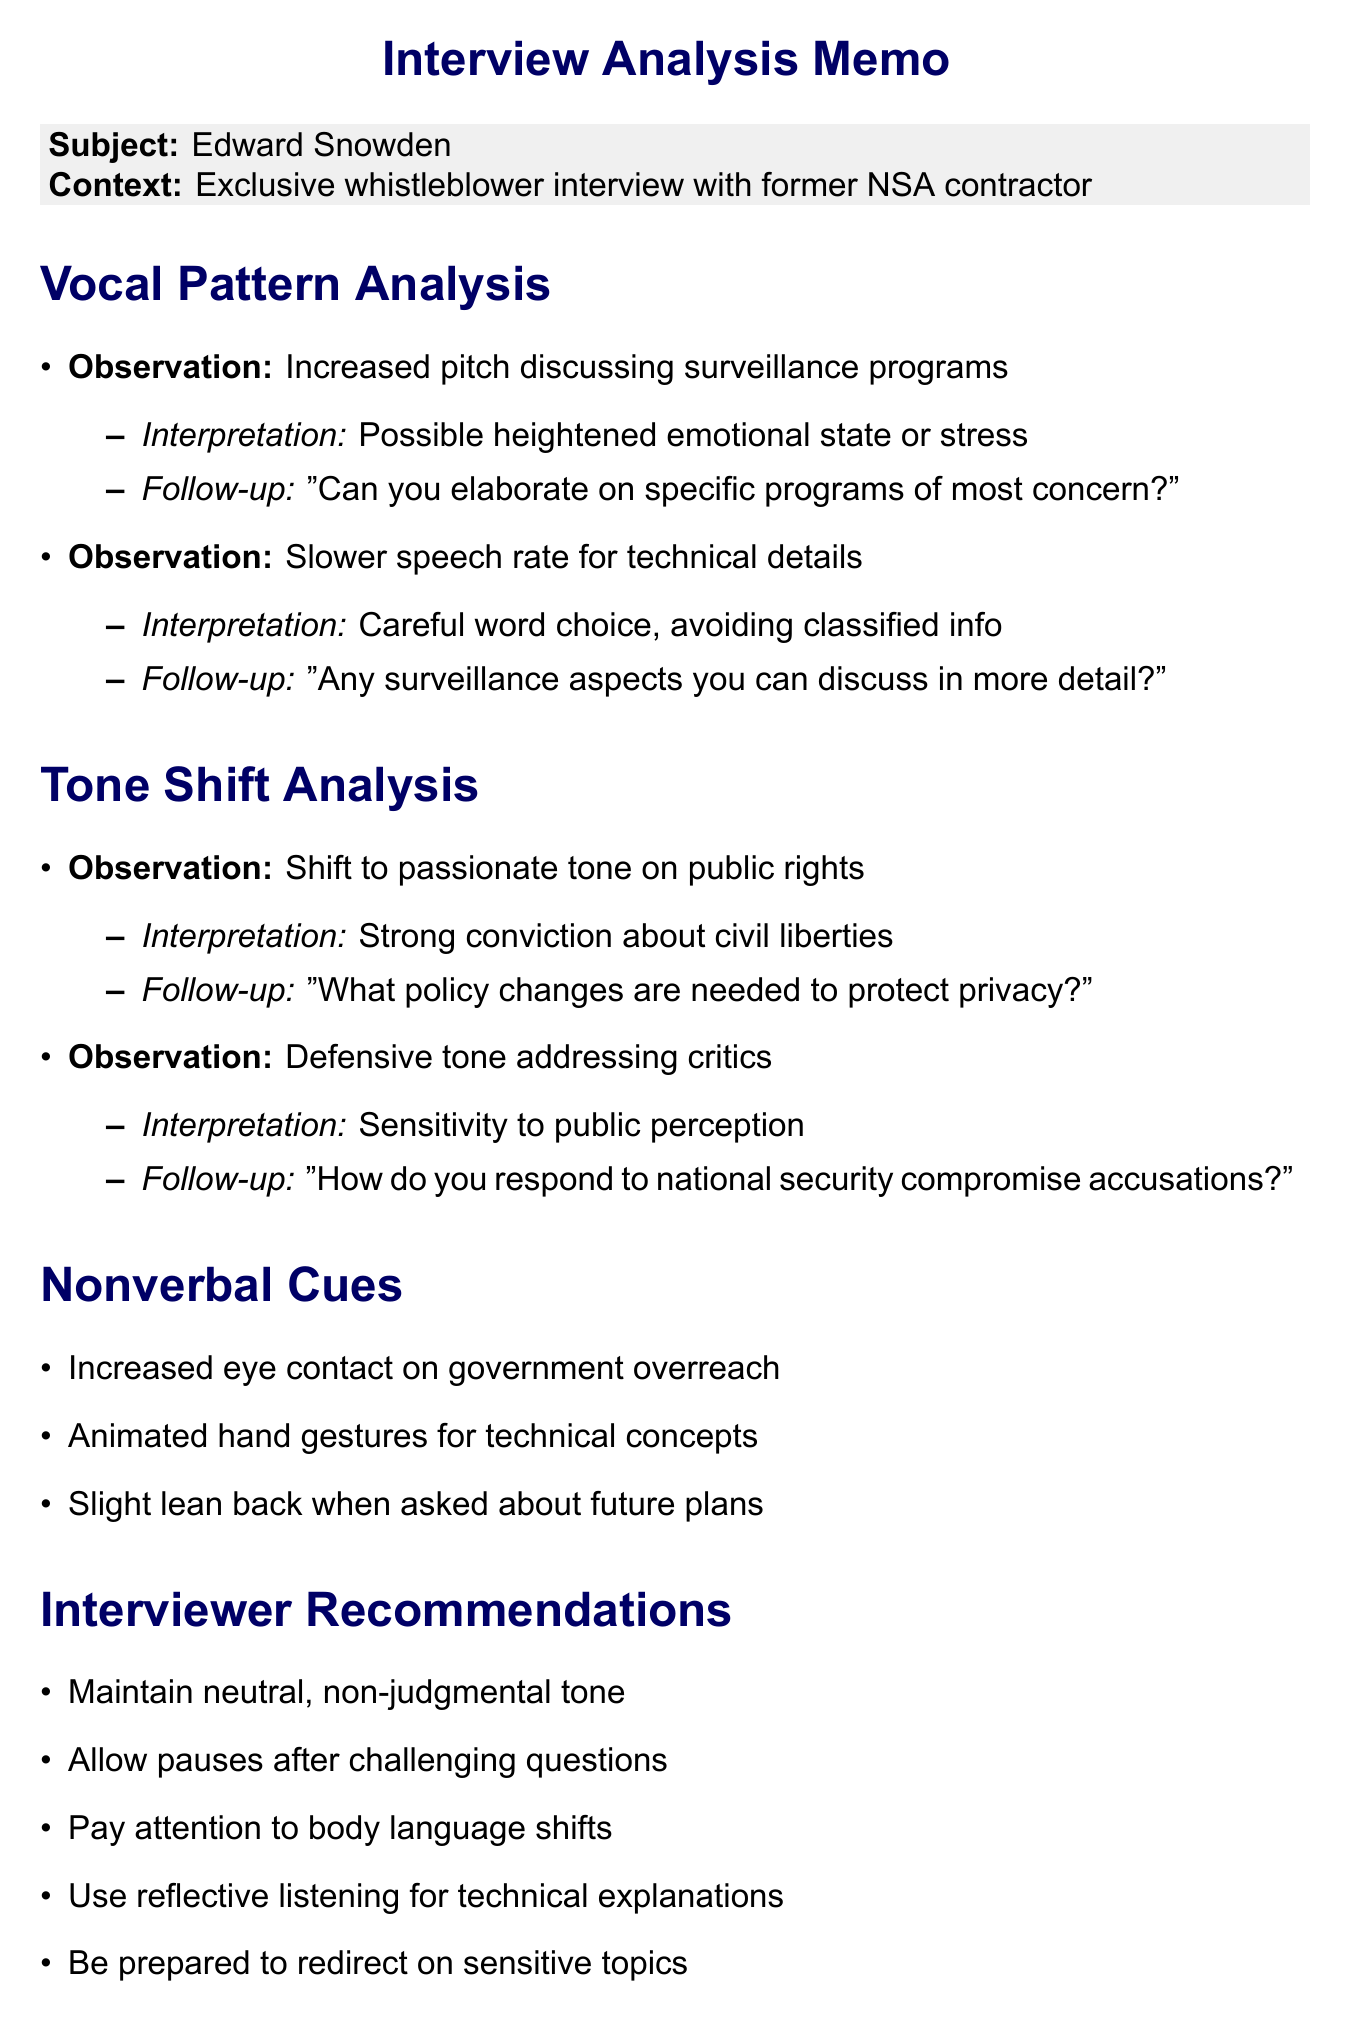What is the subject of the memo? The subject is the individual being analyzed in the interview context, which is Edward Snowden.
Answer: Edward Snowden What is the context of the interview? The context provides the setting or background for the interview, which is an exclusive whistleblower interview with a former NSA contractor.
Answer: Exclusive whistleblower interview with former NSA contractor What observation is associated with the increased pitch in vocal pattern analysis? The observation notes a specific vocal pattern related to a feeling or situation, which is increased pitch when discussing surveillance programs.
Answer: Increased pitch discussing surveillance programs What shift in tone occurs when discussing public rights? The tone shifts from a neutral or matter-of-fact demeanor to a more passionate expression, indicating strong feelings.
Answer: Passionate What recommendation is given to interviewers regarding challenging questions? The recommendation advises interviewers on how to handle tough moments in the questioning process, suggesting they allow for pauses.
Answer: Allow pauses after challenging questions What is noted about nonverbal cues when discussing government overreach? The document notes a specific nonverbal behavior related to eye contact, indicating confidence and credibility during these discussions.
Answer: Increased eye contact What potential bias is mentioned related to Snowden's notoriety? The document highlights a bias potentially affecting perception, which is related to his level of fame or reputation in the public sphere.
Answer: Halo effect What is the interpretation of a defensive tone when addressing critics? The interpretation reflects underlying feelings or concerns regarding public relations, particularly sensitivity to how the subject is viewed.
Answer: Sensitivity to public perception What does the slower speech rate during technical explanations suggest? The slower speech rate indicates a careful approach taken by the interviewee regarding specific information during discussions.
Answer: Careful word choice, avoiding classified info 